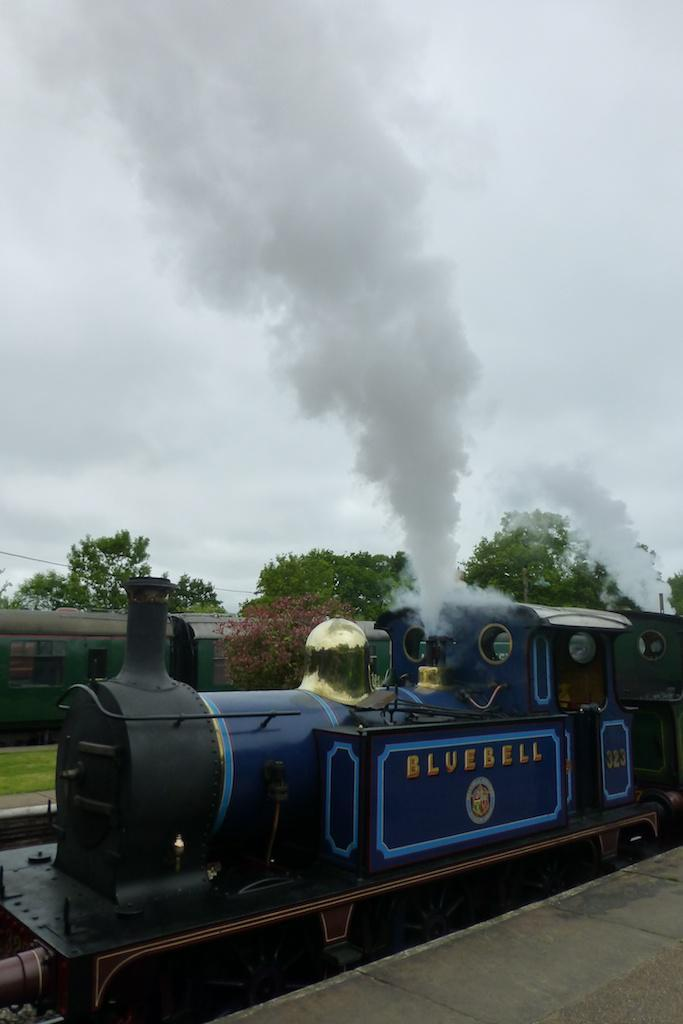What type of vehicles can be seen on the track in the image? There are trains on the track in the image. What type of vegetation is visible in the image? There are trees and grass visible in the image. What type of books is the achiever reading in the image? There is no achiever or books present in the image. How many snakes can be seen slithering through the grass in the image? There are no snakes visible in the image; it features trains on a track with trees and grass. 